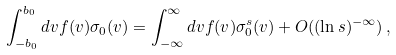<formula> <loc_0><loc_0><loc_500><loc_500>\int _ { - b _ { 0 } } ^ { b _ { 0 } } d v f ( v ) \sigma _ { 0 } ( v ) = \int _ { - \infty } ^ { \infty } d v f ( v ) \sigma _ { 0 } ^ { s } ( v ) + O ( ( { \ln s } ) ^ { - \infty } ) \, ,</formula> 